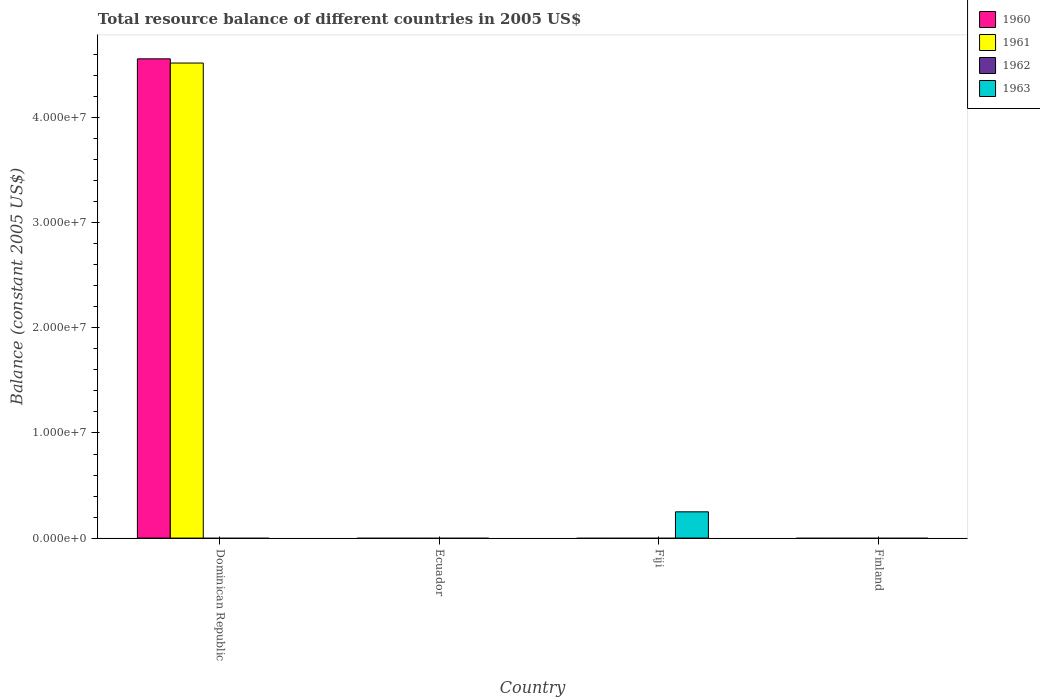How many different coloured bars are there?
Your answer should be compact. 3. Are the number of bars per tick equal to the number of legend labels?
Provide a succinct answer. No. Are the number of bars on each tick of the X-axis equal?
Keep it short and to the point. No. How many bars are there on the 2nd tick from the left?
Offer a terse response. 0. How many bars are there on the 3rd tick from the right?
Give a very brief answer. 0. What is the label of the 4th group of bars from the left?
Make the answer very short. Finland. In how many cases, is the number of bars for a given country not equal to the number of legend labels?
Offer a terse response. 4. What is the total resource balance in 1961 in Ecuador?
Give a very brief answer. 0. Across all countries, what is the maximum total resource balance in 1960?
Your response must be concise. 4.56e+07. In which country was the total resource balance in 1963 maximum?
Your answer should be very brief. Fiji. What is the total total resource balance in 1961 in the graph?
Ensure brevity in your answer.  4.52e+07. What is the average total resource balance in 1960 per country?
Make the answer very short. 1.14e+07. In how many countries, is the total resource balance in 1962 greater than 40000000 US$?
Provide a succinct answer. 0. What is the difference between the highest and the lowest total resource balance in 1963?
Make the answer very short. 2.50e+06. In how many countries, is the total resource balance in 1962 greater than the average total resource balance in 1962 taken over all countries?
Offer a terse response. 0. Is it the case that in every country, the sum of the total resource balance in 1962 and total resource balance in 1963 is greater than the sum of total resource balance in 1961 and total resource balance in 1960?
Provide a short and direct response. No. What is the difference between two consecutive major ticks on the Y-axis?
Offer a terse response. 1.00e+07. What is the title of the graph?
Make the answer very short. Total resource balance of different countries in 2005 US$. Does "1985" appear as one of the legend labels in the graph?
Offer a very short reply. No. What is the label or title of the Y-axis?
Make the answer very short. Balance (constant 2005 US$). What is the Balance (constant 2005 US$) of 1960 in Dominican Republic?
Your response must be concise. 4.56e+07. What is the Balance (constant 2005 US$) in 1961 in Dominican Republic?
Offer a very short reply. 4.52e+07. What is the Balance (constant 2005 US$) in 1962 in Dominican Republic?
Your answer should be compact. 0. What is the Balance (constant 2005 US$) of 1963 in Dominican Republic?
Give a very brief answer. 0. What is the Balance (constant 2005 US$) in 1961 in Ecuador?
Give a very brief answer. 0. What is the Balance (constant 2005 US$) of 1962 in Ecuador?
Your answer should be compact. 0. What is the Balance (constant 2005 US$) in 1960 in Fiji?
Give a very brief answer. 0. What is the Balance (constant 2005 US$) in 1961 in Fiji?
Provide a succinct answer. 0. What is the Balance (constant 2005 US$) of 1963 in Fiji?
Provide a succinct answer. 2.50e+06. What is the Balance (constant 2005 US$) of 1963 in Finland?
Offer a very short reply. 0. Across all countries, what is the maximum Balance (constant 2005 US$) of 1960?
Provide a short and direct response. 4.56e+07. Across all countries, what is the maximum Balance (constant 2005 US$) of 1961?
Your answer should be very brief. 4.52e+07. Across all countries, what is the maximum Balance (constant 2005 US$) of 1963?
Your answer should be compact. 2.50e+06. Across all countries, what is the minimum Balance (constant 2005 US$) of 1960?
Offer a terse response. 0. What is the total Balance (constant 2005 US$) of 1960 in the graph?
Your response must be concise. 4.56e+07. What is the total Balance (constant 2005 US$) of 1961 in the graph?
Offer a very short reply. 4.52e+07. What is the total Balance (constant 2005 US$) of 1963 in the graph?
Your answer should be very brief. 2.50e+06. What is the difference between the Balance (constant 2005 US$) in 1960 in Dominican Republic and the Balance (constant 2005 US$) in 1963 in Fiji?
Ensure brevity in your answer.  4.31e+07. What is the difference between the Balance (constant 2005 US$) in 1961 in Dominican Republic and the Balance (constant 2005 US$) in 1963 in Fiji?
Your answer should be very brief. 4.27e+07. What is the average Balance (constant 2005 US$) in 1960 per country?
Your answer should be compact. 1.14e+07. What is the average Balance (constant 2005 US$) in 1961 per country?
Offer a terse response. 1.13e+07. What is the average Balance (constant 2005 US$) in 1962 per country?
Give a very brief answer. 0. What is the average Balance (constant 2005 US$) of 1963 per country?
Offer a terse response. 6.25e+05. What is the difference between the Balance (constant 2005 US$) in 1960 and Balance (constant 2005 US$) in 1961 in Dominican Republic?
Offer a very short reply. 4.00e+05. What is the difference between the highest and the lowest Balance (constant 2005 US$) in 1960?
Give a very brief answer. 4.56e+07. What is the difference between the highest and the lowest Balance (constant 2005 US$) in 1961?
Ensure brevity in your answer.  4.52e+07. What is the difference between the highest and the lowest Balance (constant 2005 US$) in 1963?
Keep it short and to the point. 2.50e+06. 